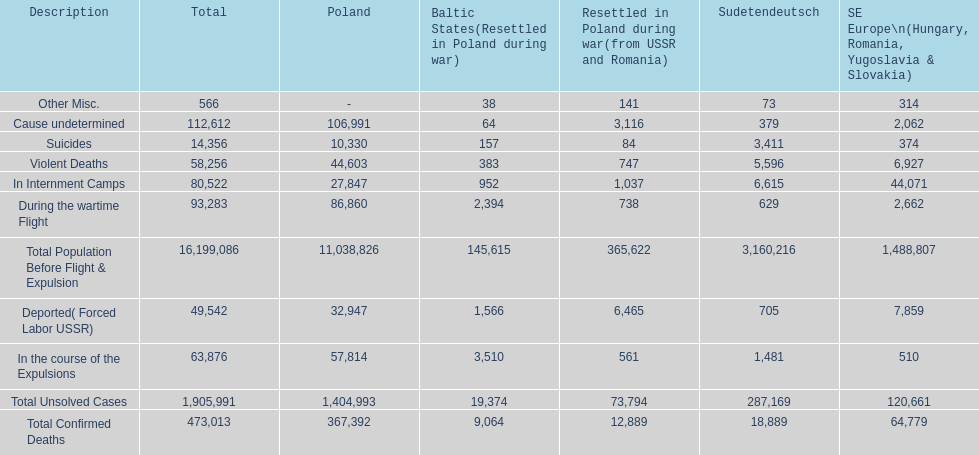Did any location have no violent deaths? No. 